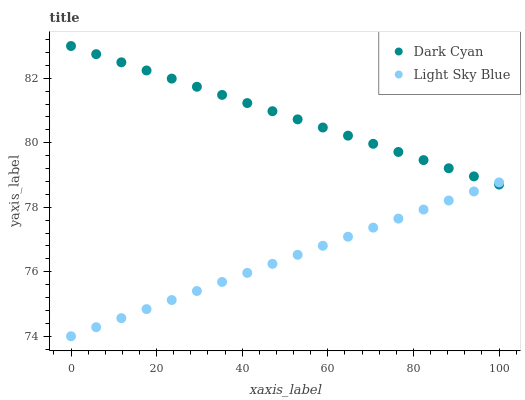Does Light Sky Blue have the minimum area under the curve?
Answer yes or no. Yes. Does Dark Cyan have the maximum area under the curve?
Answer yes or no. Yes. Does Light Sky Blue have the maximum area under the curve?
Answer yes or no. No. Is Dark Cyan the smoothest?
Answer yes or no. Yes. Is Light Sky Blue the roughest?
Answer yes or no. Yes. Is Light Sky Blue the smoothest?
Answer yes or no. No. Does Light Sky Blue have the lowest value?
Answer yes or no. Yes. Does Dark Cyan have the highest value?
Answer yes or no. Yes. Does Light Sky Blue have the highest value?
Answer yes or no. No. Does Dark Cyan intersect Light Sky Blue?
Answer yes or no. Yes. Is Dark Cyan less than Light Sky Blue?
Answer yes or no. No. Is Dark Cyan greater than Light Sky Blue?
Answer yes or no. No. 